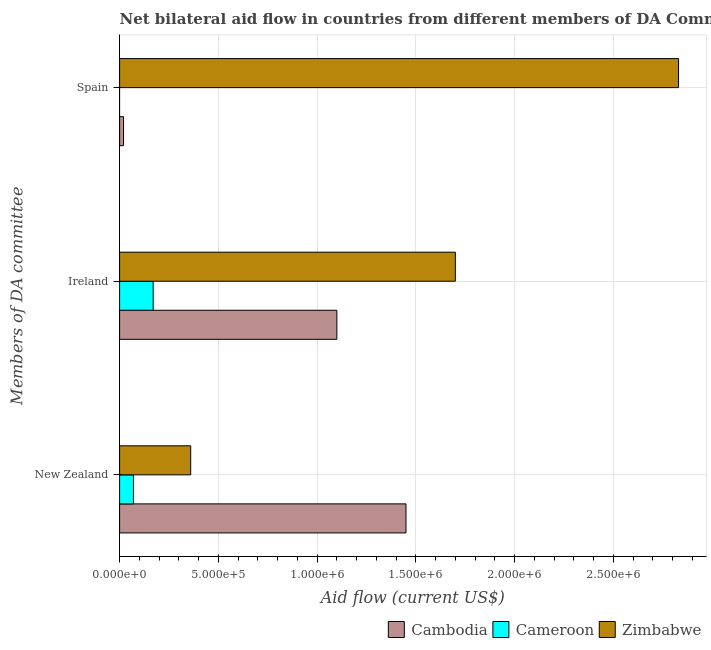Are the number of bars per tick equal to the number of legend labels?
Provide a short and direct response. No. Are the number of bars on each tick of the Y-axis equal?
Give a very brief answer. No. How many bars are there on the 2nd tick from the top?
Your answer should be very brief. 3. What is the label of the 2nd group of bars from the top?
Your response must be concise. Ireland. What is the amount of aid provided by ireland in Zimbabwe?
Offer a terse response. 1.70e+06. Across all countries, what is the maximum amount of aid provided by spain?
Give a very brief answer. 2.83e+06. Across all countries, what is the minimum amount of aid provided by ireland?
Your answer should be very brief. 1.70e+05. In which country was the amount of aid provided by ireland maximum?
Give a very brief answer. Zimbabwe. What is the total amount of aid provided by spain in the graph?
Ensure brevity in your answer.  2.85e+06. What is the difference between the amount of aid provided by spain in Zimbabwe and that in Cambodia?
Give a very brief answer. 2.81e+06. What is the difference between the amount of aid provided by spain in Zimbabwe and the amount of aid provided by ireland in Cambodia?
Ensure brevity in your answer.  1.73e+06. What is the average amount of aid provided by new zealand per country?
Offer a terse response. 6.27e+05. What is the difference between the amount of aid provided by ireland and amount of aid provided by spain in Zimbabwe?
Your response must be concise. -1.13e+06. What is the ratio of the amount of aid provided by ireland in Cameroon to that in Cambodia?
Give a very brief answer. 0.15. Is the amount of aid provided by spain in Cambodia less than that in Zimbabwe?
Your response must be concise. Yes. What is the difference between the highest and the second highest amount of aid provided by ireland?
Your response must be concise. 6.00e+05. What is the difference between the highest and the lowest amount of aid provided by spain?
Your response must be concise. 2.83e+06. Is the sum of the amount of aid provided by ireland in Zimbabwe and Cambodia greater than the maximum amount of aid provided by spain across all countries?
Ensure brevity in your answer.  No. Is it the case that in every country, the sum of the amount of aid provided by new zealand and amount of aid provided by ireland is greater than the amount of aid provided by spain?
Give a very brief answer. No. Are all the bars in the graph horizontal?
Make the answer very short. Yes. What is the difference between two consecutive major ticks on the X-axis?
Ensure brevity in your answer.  5.00e+05. Are the values on the major ticks of X-axis written in scientific E-notation?
Give a very brief answer. Yes. Does the graph contain any zero values?
Ensure brevity in your answer.  Yes. Does the graph contain grids?
Your response must be concise. Yes. Where does the legend appear in the graph?
Your answer should be compact. Bottom right. How many legend labels are there?
Ensure brevity in your answer.  3. What is the title of the graph?
Ensure brevity in your answer.  Net bilateral aid flow in countries from different members of DA Committee. Does "Uganda" appear as one of the legend labels in the graph?
Offer a very short reply. No. What is the label or title of the X-axis?
Make the answer very short. Aid flow (current US$). What is the label or title of the Y-axis?
Keep it short and to the point. Members of DA committee. What is the Aid flow (current US$) of Cambodia in New Zealand?
Keep it short and to the point. 1.45e+06. What is the Aid flow (current US$) in Cameroon in New Zealand?
Your response must be concise. 7.00e+04. What is the Aid flow (current US$) in Cambodia in Ireland?
Offer a very short reply. 1.10e+06. What is the Aid flow (current US$) of Zimbabwe in Ireland?
Your response must be concise. 1.70e+06. What is the Aid flow (current US$) of Cambodia in Spain?
Give a very brief answer. 2.00e+04. What is the Aid flow (current US$) of Cameroon in Spain?
Offer a terse response. 0. What is the Aid flow (current US$) in Zimbabwe in Spain?
Your answer should be compact. 2.83e+06. Across all Members of DA committee, what is the maximum Aid flow (current US$) in Cambodia?
Give a very brief answer. 1.45e+06. Across all Members of DA committee, what is the maximum Aid flow (current US$) of Zimbabwe?
Ensure brevity in your answer.  2.83e+06. Across all Members of DA committee, what is the minimum Aid flow (current US$) in Cameroon?
Give a very brief answer. 0. Across all Members of DA committee, what is the minimum Aid flow (current US$) of Zimbabwe?
Ensure brevity in your answer.  3.60e+05. What is the total Aid flow (current US$) of Cambodia in the graph?
Keep it short and to the point. 2.57e+06. What is the total Aid flow (current US$) of Cameroon in the graph?
Offer a terse response. 2.40e+05. What is the total Aid flow (current US$) of Zimbabwe in the graph?
Offer a terse response. 4.89e+06. What is the difference between the Aid flow (current US$) of Cambodia in New Zealand and that in Ireland?
Offer a very short reply. 3.50e+05. What is the difference between the Aid flow (current US$) of Cameroon in New Zealand and that in Ireland?
Make the answer very short. -1.00e+05. What is the difference between the Aid flow (current US$) in Zimbabwe in New Zealand and that in Ireland?
Your response must be concise. -1.34e+06. What is the difference between the Aid flow (current US$) in Cambodia in New Zealand and that in Spain?
Give a very brief answer. 1.43e+06. What is the difference between the Aid flow (current US$) in Zimbabwe in New Zealand and that in Spain?
Give a very brief answer. -2.47e+06. What is the difference between the Aid flow (current US$) in Cambodia in Ireland and that in Spain?
Offer a terse response. 1.08e+06. What is the difference between the Aid flow (current US$) in Zimbabwe in Ireland and that in Spain?
Keep it short and to the point. -1.13e+06. What is the difference between the Aid flow (current US$) of Cambodia in New Zealand and the Aid flow (current US$) of Cameroon in Ireland?
Make the answer very short. 1.28e+06. What is the difference between the Aid flow (current US$) of Cambodia in New Zealand and the Aid flow (current US$) of Zimbabwe in Ireland?
Provide a succinct answer. -2.50e+05. What is the difference between the Aid flow (current US$) of Cameroon in New Zealand and the Aid flow (current US$) of Zimbabwe in Ireland?
Offer a very short reply. -1.63e+06. What is the difference between the Aid flow (current US$) in Cambodia in New Zealand and the Aid flow (current US$) in Zimbabwe in Spain?
Your answer should be compact. -1.38e+06. What is the difference between the Aid flow (current US$) in Cameroon in New Zealand and the Aid flow (current US$) in Zimbabwe in Spain?
Your answer should be compact. -2.76e+06. What is the difference between the Aid flow (current US$) in Cambodia in Ireland and the Aid flow (current US$) in Zimbabwe in Spain?
Provide a succinct answer. -1.73e+06. What is the difference between the Aid flow (current US$) in Cameroon in Ireland and the Aid flow (current US$) in Zimbabwe in Spain?
Offer a terse response. -2.66e+06. What is the average Aid flow (current US$) of Cambodia per Members of DA committee?
Give a very brief answer. 8.57e+05. What is the average Aid flow (current US$) in Cameroon per Members of DA committee?
Offer a very short reply. 8.00e+04. What is the average Aid flow (current US$) of Zimbabwe per Members of DA committee?
Your answer should be compact. 1.63e+06. What is the difference between the Aid flow (current US$) in Cambodia and Aid flow (current US$) in Cameroon in New Zealand?
Offer a very short reply. 1.38e+06. What is the difference between the Aid flow (current US$) in Cambodia and Aid flow (current US$) in Zimbabwe in New Zealand?
Offer a terse response. 1.09e+06. What is the difference between the Aid flow (current US$) in Cambodia and Aid flow (current US$) in Cameroon in Ireland?
Your response must be concise. 9.30e+05. What is the difference between the Aid flow (current US$) of Cambodia and Aid flow (current US$) of Zimbabwe in Ireland?
Give a very brief answer. -6.00e+05. What is the difference between the Aid flow (current US$) of Cameroon and Aid flow (current US$) of Zimbabwe in Ireland?
Give a very brief answer. -1.53e+06. What is the difference between the Aid flow (current US$) of Cambodia and Aid flow (current US$) of Zimbabwe in Spain?
Provide a short and direct response. -2.81e+06. What is the ratio of the Aid flow (current US$) in Cambodia in New Zealand to that in Ireland?
Offer a very short reply. 1.32. What is the ratio of the Aid flow (current US$) of Cameroon in New Zealand to that in Ireland?
Ensure brevity in your answer.  0.41. What is the ratio of the Aid flow (current US$) of Zimbabwe in New Zealand to that in Ireland?
Make the answer very short. 0.21. What is the ratio of the Aid flow (current US$) in Cambodia in New Zealand to that in Spain?
Provide a succinct answer. 72.5. What is the ratio of the Aid flow (current US$) of Zimbabwe in New Zealand to that in Spain?
Make the answer very short. 0.13. What is the ratio of the Aid flow (current US$) of Cambodia in Ireland to that in Spain?
Give a very brief answer. 55. What is the ratio of the Aid flow (current US$) in Zimbabwe in Ireland to that in Spain?
Keep it short and to the point. 0.6. What is the difference between the highest and the second highest Aid flow (current US$) of Cambodia?
Provide a short and direct response. 3.50e+05. What is the difference between the highest and the second highest Aid flow (current US$) in Zimbabwe?
Keep it short and to the point. 1.13e+06. What is the difference between the highest and the lowest Aid flow (current US$) in Cambodia?
Provide a short and direct response. 1.43e+06. What is the difference between the highest and the lowest Aid flow (current US$) of Zimbabwe?
Your answer should be compact. 2.47e+06. 